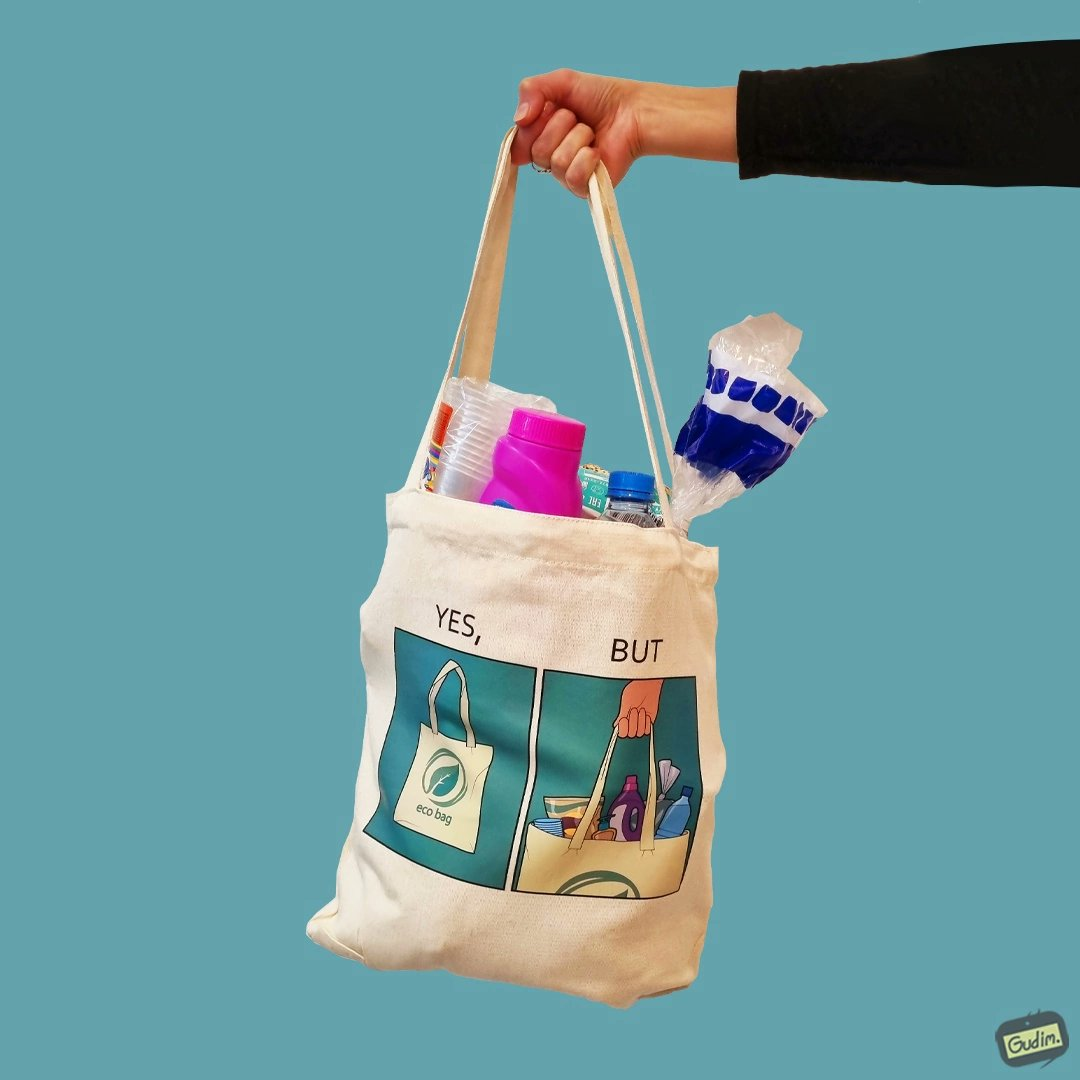What is the satirical meaning behind this image? The image is ironical because in the left image it is written eco bag but in the right image we are keeping items of plastic which is not eco-friendly. 